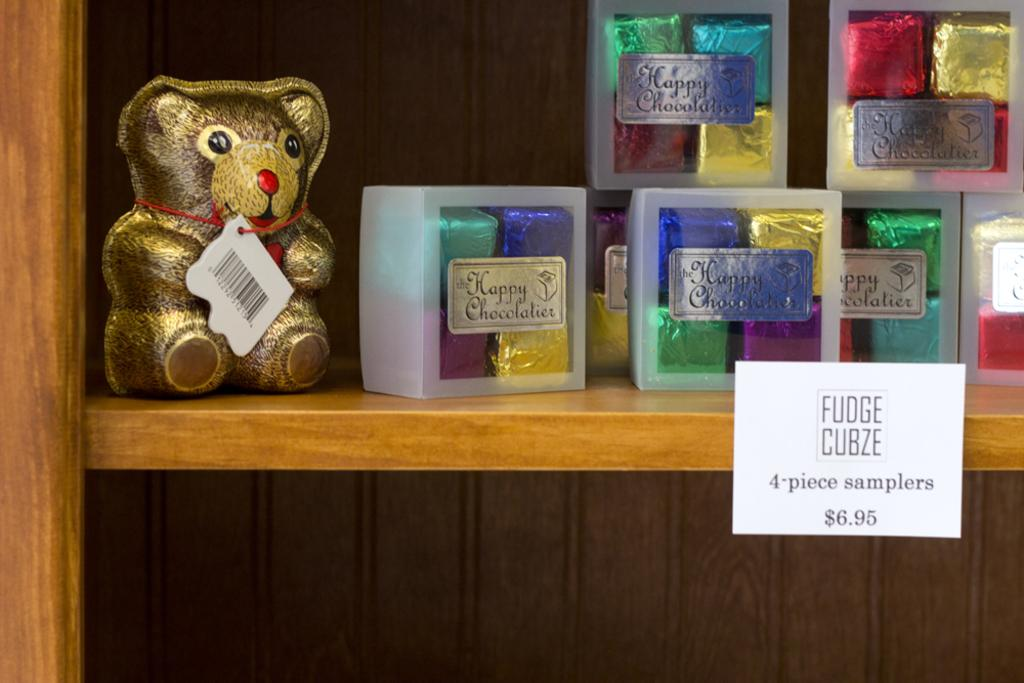<image>
Create a compact narrative representing the image presented. Chocolates packaged and on display labeled 4-piece sampler. 